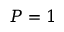Convert formula to latex. <formula><loc_0><loc_0><loc_500><loc_500>P = 1</formula> 